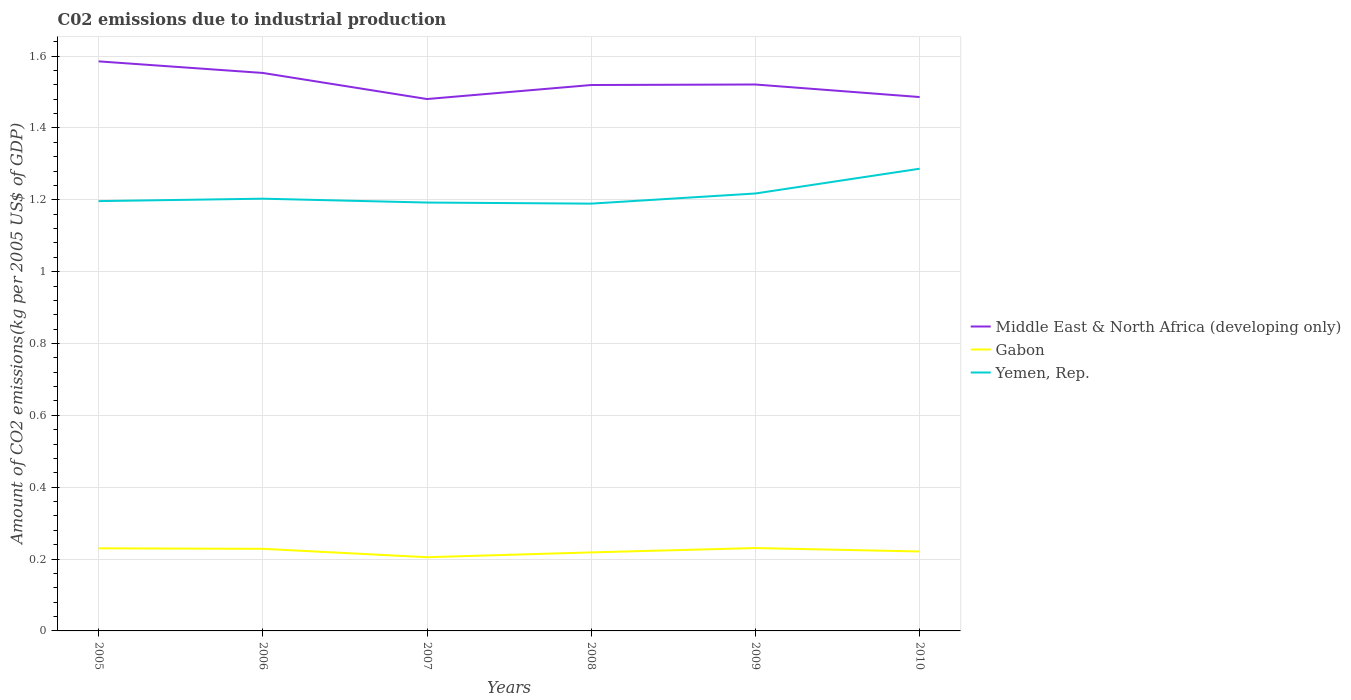Does the line corresponding to Yemen, Rep. intersect with the line corresponding to Gabon?
Your response must be concise. No. Across all years, what is the maximum amount of CO2 emitted due to industrial production in Yemen, Rep.?
Offer a terse response. 1.19. In which year was the amount of CO2 emitted due to industrial production in Yemen, Rep. maximum?
Keep it short and to the point. 2008. What is the total amount of CO2 emitted due to industrial production in Yemen, Rep. in the graph?
Provide a succinct answer. -0.07. What is the difference between the highest and the second highest amount of CO2 emitted due to industrial production in Gabon?
Your answer should be compact. 0.03. What is the difference between the highest and the lowest amount of CO2 emitted due to industrial production in Middle East & North Africa (developing only)?
Your answer should be very brief. 2. How many lines are there?
Your response must be concise. 3. How many years are there in the graph?
Make the answer very short. 6. What is the difference between two consecutive major ticks on the Y-axis?
Provide a short and direct response. 0.2. Are the values on the major ticks of Y-axis written in scientific E-notation?
Give a very brief answer. No. Does the graph contain any zero values?
Provide a succinct answer. No. Does the graph contain grids?
Give a very brief answer. Yes. Where does the legend appear in the graph?
Ensure brevity in your answer.  Center right. How many legend labels are there?
Ensure brevity in your answer.  3. What is the title of the graph?
Give a very brief answer. C02 emissions due to industrial production. What is the label or title of the X-axis?
Provide a succinct answer. Years. What is the label or title of the Y-axis?
Your answer should be compact. Amount of CO2 emissions(kg per 2005 US$ of GDP). What is the Amount of CO2 emissions(kg per 2005 US$ of GDP) in Middle East & North Africa (developing only) in 2005?
Give a very brief answer. 1.59. What is the Amount of CO2 emissions(kg per 2005 US$ of GDP) in Gabon in 2005?
Give a very brief answer. 0.23. What is the Amount of CO2 emissions(kg per 2005 US$ of GDP) in Yemen, Rep. in 2005?
Give a very brief answer. 1.2. What is the Amount of CO2 emissions(kg per 2005 US$ of GDP) in Middle East & North Africa (developing only) in 2006?
Provide a short and direct response. 1.55. What is the Amount of CO2 emissions(kg per 2005 US$ of GDP) in Gabon in 2006?
Make the answer very short. 0.23. What is the Amount of CO2 emissions(kg per 2005 US$ of GDP) of Yemen, Rep. in 2006?
Keep it short and to the point. 1.2. What is the Amount of CO2 emissions(kg per 2005 US$ of GDP) in Middle East & North Africa (developing only) in 2007?
Your answer should be very brief. 1.48. What is the Amount of CO2 emissions(kg per 2005 US$ of GDP) in Gabon in 2007?
Keep it short and to the point. 0.21. What is the Amount of CO2 emissions(kg per 2005 US$ of GDP) in Yemen, Rep. in 2007?
Make the answer very short. 1.19. What is the Amount of CO2 emissions(kg per 2005 US$ of GDP) in Middle East & North Africa (developing only) in 2008?
Offer a very short reply. 1.52. What is the Amount of CO2 emissions(kg per 2005 US$ of GDP) of Gabon in 2008?
Offer a very short reply. 0.22. What is the Amount of CO2 emissions(kg per 2005 US$ of GDP) in Yemen, Rep. in 2008?
Provide a short and direct response. 1.19. What is the Amount of CO2 emissions(kg per 2005 US$ of GDP) in Middle East & North Africa (developing only) in 2009?
Give a very brief answer. 1.52. What is the Amount of CO2 emissions(kg per 2005 US$ of GDP) in Gabon in 2009?
Make the answer very short. 0.23. What is the Amount of CO2 emissions(kg per 2005 US$ of GDP) of Yemen, Rep. in 2009?
Ensure brevity in your answer.  1.22. What is the Amount of CO2 emissions(kg per 2005 US$ of GDP) in Middle East & North Africa (developing only) in 2010?
Keep it short and to the point. 1.49. What is the Amount of CO2 emissions(kg per 2005 US$ of GDP) of Gabon in 2010?
Offer a very short reply. 0.22. What is the Amount of CO2 emissions(kg per 2005 US$ of GDP) of Yemen, Rep. in 2010?
Your answer should be compact. 1.29. Across all years, what is the maximum Amount of CO2 emissions(kg per 2005 US$ of GDP) of Middle East & North Africa (developing only)?
Give a very brief answer. 1.59. Across all years, what is the maximum Amount of CO2 emissions(kg per 2005 US$ of GDP) of Gabon?
Your answer should be very brief. 0.23. Across all years, what is the maximum Amount of CO2 emissions(kg per 2005 US$ of GDP) in Yemen, Rep.?
Provide a short and direct response. 1.29. Across all years, what is the minimum Amount of CO2 emissions(kg per 2005 US$ of GDP) in Middle East & North Africa (developing only)?
Make the answer very short. 1.48. Across all years, what is the minimum Amount of CO2 emissions(kg per 2005 US$ of GDP) of Gabon?
Ensure brevity in your answer.  0.21. Across all years, what is the minimum Amount of CO2 emissions(kg per 2005 US$ of GDP) in Yemen, Rep.?
Your answer should be very brief. 1.19. What is the total Amount of CO2 emissions(kg per 2005 US$ of GDP) in Middle East & North Africa (developing only) in the graph?
Ensure brevity in your answer.  9.15. What is the total Amount of CO2 emissions(kg per 2005 US$ of GDP) of Gabon in the graph?
Your response must be concise. 1.33. What is the total Amount of CO2 emissions(kg per 2005 US$ of GDP) of Yemen, Rep. in the graph?
Give a very brief answer. 7.29. What is the difference between the Amount of CO2 emissions(kg per 2005 US$ of GDP) of Middle East & North Africa (developing only) in 2005 and that in 2006?
Offer a very short reply. 0.03. What is the difference between the Amount of CO2 emissions(kg per 2005 US$ of GDP) of Gabon in 2005 and that in 2006?
Ensure brevity in your answer.  0. What is the difference between the Amount of CO2 emissions(kg per 2005 US$ of GDP) in Yemen, Rep. in 2005 and that in 2006?
Ensure brevity in your answer.  -0.01. What is the difference between the Amount of CO2 emissions(kg per 2005 US$ of GDP) of Middle East & North Africa (developing only) in 2005 and that in 2007?
Offer a terse response. 0.1. What is the difference between the Amount of CO2 emissions(kg per 2005 US$ of GDP) of Gabon in 2005 and that in 2007?
Your answer should be very brief. 0.02. What is the difference between the Amount of CO2 emissions(kg per 2005 US$ of GDP) in Yemen, Rep. in 2005 and that in 2007?
Ensure brevity in your answer.  0. What is the difference between the Amount of CO2 emissions(kg per 2005 US$ of GDP) in Middle East & North Africa (developing only) in 2005 and that in 2008?
Make the answer very short. 0.07. What is the difference between the Amount of CO2 emissions(kg per 2005 US$ of GDP) in Gabon in 2005 and that in 2008?
Your answer should be compact. 0.01. What is the difference between the Amount of CO2 emissions(kg per 2005 US$ of GDP) in Yemen, Rep. in 2005 and that in 2008?
Your answer should be very brief. 0.01. What is the difference between the Amount of CO2 emissions(kg per 2005 US$ of GDP) in Middle East & North Africa (developing only) in 2005 and that in 2009?
Offer a very short reply. 0.06. What is the difference between the Amount of CO2 emissions(kg per 2005 US$ of GDP) in Gabon in 2005 and that in 2009?
Your response must be concise. -0. What is the difference between the Amount of CO2 emissions(kg per 2005 US$ of GDP) of Yemen, Rep. in 2005 and that in 2009?
Give a very brief answer. -0.02. What is the difference between the Amount of CO2 emissions(kg per 2005 US$ of GDP) of Middle East & North Africa (developing only) in 2005 and that in 2010?
Offer a very short reply. 0.1. What is the difference between the Amount of CO2 emissions(kg per 2005 US$ of GDP) in Gabon in 2005 and that in 2010?
Your response must be concise. 0.01. What is the difference between the Amount of CO2 emissions(kg per 2005 US$ of GDP) of Yemen, Rep. in 2005 and that in 2010?
Provide a short and direct response. -0.09. What is the difference between the Amount of CO2 emissions(kg per 2005 US$ of GDP) of Middle East & North Africa (developing only) in 2006 and that in 2007?
Your answer should be compact. 0.07. What is the difference between the Amount of CO2 emissions(kg per 2005 US$ of GDP) of Gabon in 2006 and that in 2007?
Your answer should be compact. 0.02. What is the difference between the Amount of CO2 emissions(kg per 2005 US$ of GDP) of Yemen, Rep. in 2006 and that in 2007?
Your answer should be very brief. 0.01. What is the difference between the Amount of CO2 emissions(kg per 2005 US$ of GDP) in Middle East & North Africa (developing only) in 2006 and that in 2008?
Provide a succinct answer. 0.03. What is the difference between the Amount of CO2 emissions(kg per 2005 US$ of GDP) in Gabon in 2006 and that in 2008?
Give a very brief answer. 0.01. What is the difference between the Amount of CO2 emissions(kg per 2005 US$ of GDP) in Yemen, Rep. in 2006 and that in 2008?
Keep it short and to the point. 0.01. What is the difference between the Amount of CO2 emissions(kg per 2005 US$ of GDP) of Middle East & North Africa (developing only) in 2006 and that in 2009?
Your response must be concise. 0.03. What is the difference between the Amount of CO2 emissions(kg per 2005 US$ of GDP) in Gabon in 2006 and that in 2009?
Provide a short and direct response. -0. What is the difference between the Amount of CO2 emissions(kg per 2005 US$ of GDP) of Yemen, Rep. in 2006 and that in 2009?
Your response must be concise. -0.01. What is the difference between the Amount of CO2 emissions(kg per 2005 US$ of GDP) of Middle East & North Africa (developing only) in 2006 and that in 2010?
Make the answer very short. 0.07. What is the difference between the Amount of CO2 emissions(kg per 2005 US$ of GDP) of Gabon in 2006 and that in 2010?
Your response must be concise. 0.01. What is the difference between the Amount of CO2 emissions(kg per 2005 US$ of GDP) of Yemen, Rep. in 2006 and that in 2010?
Offer a terse response. -0.08. What is the difference between the Amount of CO2 emissions(kg per 2005 US$ of GDP) in Middle East & North Africa (developing only) in 2007 and that in 2008?
Offer a very short reply. -0.04. What is the difference between the Amount of CO2 emissions(kg per 2005 US$ of GDP) of Gabon in 2007 and that in 2008?
Give a very brief answer. -0.01. What is the difference between the Amount of CO2 emissions(kg per 2005 US$ of GDP) in Yemen, Rep. in 2007 and that in 2008?
Offer a very short reply. 0. What is the difference between the Amount of CO2 emissions(kg per 2005 US$ of GDP) of Middle East & North Africa (developing only) in 2007 and that in 2009?
Provide a succinct answer. -0.04. What is the difference between the Amount of CO2 emissions(kg per 2005 US$ of GDP) in Gabon in 2007 and that in 2009?
Provide a short and direct response. -0.03. What is the difference between the Amount of CO2 emissions(kg per 2005 US$ of GDP) in Yemen, Rep. in 2007 and that in 2009?
Provide a short and direct response. -0.03. What is the difference between the Amount of CO2 emissions(kg per 2005 US$ of GDP) of Middle East & North Africa (developing only) in 2007 and that in 2010?
Your answer should be very brief. -0.01. What is the difference between the Amount of CO2 emissions(kg per 2005 US$ of GDP) of Gabon in 2007 and that in 2010?
Offer a terse response. -0.02. What is the difference between the Amount of CO2 emissions(kg per 2005 US$ of GDP) in Yemen, Rep. in 2007 and that in 2010?
Your response must be concise. -0.09. What is the difference between the Amount of CO2 emissions(kg per 2005 US$ of GDP) in Middle East & North Africa (developing only) in 2008 and that in 2009?
Make the answer very short. -0. What is the difference between the Amount of CO2 emissions(kg per 2005 US$ of GDP) in Gabon in 2008 and that in 2009?
Offer a very short reply. -0.01. What is the difference between the Amount of CO2 emissions(kg per 2005 US$ of GDP) of Yemen, Rep. in 2008 and that in 2009?
Your answer should be very brief. -0.03. What is the difference between the Amount of CO2 emissions(kg per 2005 US$ of GDP) of Middle East & North Africa (developing only) in 2008 and that in 2010?
Give a very brief answer. 0.03. What is the difference between the Amount of CO2 emissions(kg per 2005 US$ of GDP) in Gabon in 2008 and that in 2010?
Keep it short and to the point. -0. What is the difference between the Amount of CO2 emissions(kg per 2005 US$ of GDP) in Yemen, Rep. in 2008 and that in 2010?
Your response must be concise. -0.1. What is the difference between the Amount of CO2 emissions(kg per 2005 US$ of GDP) in Middle East & North Africa (developing only) in 2009 and that in 2010?
Your response must be concise. 0.03. What is the difference between the Amount of CO2 emissions(kg per 2005 US$ of GDP) of Gabon in 2009 and that in 2010?
Your answer should be very brief. 0.01. What is the difference between the Amount of CO2 emissions(kg per 2005 US$ of GDP) in Yemen, Rep. in 2009 and that in 2010?
Provide a succinct answer. -0.07. What is the difference between the Amount of CO2 emissions(kg per 2005 US$ of GDP) of Middle East & North Africa (developing only) in 2005 and the Amount of CO2 emissions(kg per 2005 US$ of GDP) of Gabon in 2006?
Offer a very short reply. 1.36. What is the difference between the Amount of CO2 emissions(kg per 2005 US$ of GDP) of Middle East & North Africa (developing only) in 2005 and the Amount of CO2 emissions(kg per 2005 US$ of GDP) of Yemen, Rep. in 2006?
Provide a succinct answer. 0.38. What is the difference between the Amount of CO2 emissions(kg per 2005 US$ of GDP) in Gabon in 2005 and the Amount of CO2 emissions(kg per 2005 US$ of GDP) in Yemen, Rep. in 2006?
Your response must be concise. -0.97. What is the difference between the Amount of CO2 emissions(kg per 2005 US$ of GDP) in Middle East & North Africa (developing only) in 2005 and the Amount of CO2 emissions(kg per 2005 US$ of GDP) in Gabon in 2007?
Provide a succinct answer. 1.38. What is the difference between the Amount of CO2 emissions(kg per 2005 US$ of GDP) in Middle East & North Africa (developing only) in 2005 and the Amount of CO2 emissions(kg per 2005 US$ of GDP) in Yemen, Rep. in 2007?
Your response must be concise. 0.39. What is the difference between the Amount of CO2 emissions(kg per 2005 US$ of GDP) in Gabon in 2005 and the Amount of CO2 emissions(kg per 2005 US$ of GDP) in Yemen, Rep. in 2007?
Offer a terse response. -0.96. What is the difference between the Amount of CO2 emissions(kg per 2005 US$ of GDP) of Middle East & North Africa (developing only) in 2005 and the Amount of CO2 emissions(kg per 2005 US$ of GDP) of Gabon in 2008?
Make the answer very short. 1.37. What is the difference between the Amount of CO2 emissions(kg per 2005 US$ of GDP) in Middle East & North Africa (developing only) in 2005 and the Amount of CO2 emissions(kg per 2005 US$ of GDP) in Yemen, Rep. in 2008?
Your answer should be compact. 0.4. What is the difference between the Amount of CO2 emissions(kg per 2005 US$ of GDP) in Gabon in 2005 and the Amount of CO2 emissions(kg per 2005 US$ of GDP) in Yemen, Rep. in 2008?
Provide a succinct answer. -0.96. What is the difference between the Amount of CO2 emissions(kg per 2005 US$ of GDP) of Middle East & North Africa (developing only) in 2005 and the Amount of CO2 emissions(kg per 2005 US$ of GDP) of Gabon in 2009?
Your answer should be compact. 1.35. What is the difference between the Amount of CO2 emissions(kg per 2005 US$ of GDP) in Middle East & North Africa (developing only) in 2005 and the Amount of CO2 emissions(kg per 2005 US$ of GDP) in Yemen, Rep. in 2009?
Your answer should be compact. 0.37. What is the difference between the Amount of CO2 emissions(kg per 2005 US$ of GDP) in Gabon in 2005 and the Amount of CO2 emissions(kg per 2005 US$ of GDP) in Yemen, Rep. in 2009?
Your answer should be compact. -0.99. What is the difference between the Amount of CO2 emissions(kg per 2005 US$ of GDP) in Middle East & North Africa (developing only) in 2005 and the Amount of CO2 emissions(kg per 2005 US$ of GDP) in Gabon in 2010?
Give a very brief answer. 1.36. What is the difference between the Amount of CO2 emissions(kg per 2005 US$ of GDP) of Middle East & North Africa (developing only) in 2005 and the Amount of CO2 emissions(kg per 2005 US$ of GDP) of Yemen, Rep. in 2010?
Offer a very short reply. 0.3. What is the difference between the Amount of CO2 emissions(kg per 2005 US$ of GDP) of Gabon in 2005 and the Amount of CO2 emissions(kg per 2005 US$ of GDP) of Yemen, Rep. in 2010?
Make the answer very short. -1.06. What is the difference between the Amount of CO2 emissions(kg per 2005 US$ of GDP) of Middle East & North Africa (developing only) in 2006 and the Amount of CO2 emissions(kg per 2005 US$ of GDP) of Gabon in 2007?
Your answer should be compact. 1.35. What is the difference between the Amount of CO2 emissions(kg per 2005 US$ of GDP) in Middle East & North Africa (developing only) in 2006 and the Amount of CO2 emissions(kg per 2005 US$ of GDP) in Yemen, Rep. in 2007?
Offer a very short reply. 0.36. What is the difference between the Amount of CO2 emissions(kg per 2005 US$ of GDP) of Gabon in 2006 and the Amount of CO2 emissions(kg per 2005 US$ of GDP) of Yemen, Rep. in 2007?
Offer a very short reply. -0.96. What is the difference between the Amount of CO2 emissions(kg per 2005 US$ of GDP) of Middle East & North Africa (developing only) in 2006 and the Amount of CO2 emissions(kg per 2005 US$ of GDP) of Gabon in 2008?
Your answer should be compact. 1.33. What is the difference between the Amount of CO2 emissions(kg per 2005 US$ of GDP) in Middle East & North Africa (developing only) in 2006 and the Amount of CO2 emissions(kg per 2005 US$ of GDP) in Yemen, Rep. in 2008?
Offer a terse response. 0.36. What is the difference between the Amount of CO2 emissions(kg per 2005 US$ of GDP) in Gabon in 2006 and the Amount of CO2 emissions(kg per 2005 US$ of GDP) in Yemen, Rep. in 2008?
Ensure brevity in your answer.  -0.96. What is the difference between the Amount of CO2 emissions(kg per 2005 US$ of GDP) in Middle East & North Africa (developing only) in 2006 and the Amount of CO2 emissions(kg per 2005 US$ of GDP) in Gabon in 2009?
Your answer should be compact. 1.32. What is the difference between the Amount of CO2 emissions(kg per 2005 US$ of GDP) in Middle East & North Africa (developing only) in 2006 and the Amount of CO2 emissions(kg per 2005 US$ of GDP) in Yemen, Rep. in 2009?
Give a very brief answer. 0.34. What is the difference between the Amount of CO2 emissions(kg per 2005 US$ of GDP) in Gabon in 2006 and the Amount of CO2 emissions(kg per 2005 US$ of GDP) in Yemen, Rep. in 2009?
Your answer should be very brief. -0.99. What is the difference between the Amount of CO2 emissions(kg per 2005 US$ of GDP) in Middle East & North Africa (developing only) in 2006 and the Amount of CO2 emissions(kg per 2005 US$ of GDP) in Gabon in 2010?
Your answer should be compact. 1.33. What is the difference between the Amount of CO2 emissions(kg per 2005 US$ of GDP) in Middle East & North Africa (developing only) in 2006 and the Amount of CO2 emissions(kg per 2005 US$ of GDP) in Yemen, Rep. in 2010?
Give a very brief answer. 0.27. What is the difference between the Amount of CO2 emissions(kg per 2005 US$ of GDP) in Gabon in 2006 and the Amount of CO2 emissions(kg per 2005 US$ of GDP) in Yemen, Rep. in 2010?
Your answer should be compact. -1.06. What is the difference between the Amount of CO2 emissions(kg per 2005 US$ of GDP) in Middle East & North Africa (developing only) in 2007 and the Amount of CO2 emissions(kg per 2005 US$ of GDP) in Gabon in 2008?
Keep it short and to the point. 1.26. What is the difference between the Amount of CO2 emissions(kg per 2005 US$ of GDP) in Middle East & North Africa (developing only) in 2007 and the Amount of CO2 emissions(kg per 2005 US$ of GDP) in Yemen, Rep. in 2008?
Ensure brevity in your answer.  0.29. What is the difference between the Amount of CO2 emissions(kg per 2005 US$ of GDP) in Gabon in 2007 and the Amount of CO2 emissions(kg per 2005 US$ of GDP) in Yemen, Rep. in 2008?
Your response must be concise. -0.98. What is the difference between the Amount of CO2 emissions(kg per 2005 US$ of GDP) in Middle East & North Africa (developing only) in 2007 and the Amount of CO2 emissions(kg per 2005 US$ of GDP) in Gabon in 2009?
Your answer should be very brief. 1.25. What is the difference between the Amount of CO2 emissions(kg per 2005 US$ of GDP) in Middle East & North Africa (developing only) in 2007 and the Amount of CO2 emissions(kg per 2005 US$ of GDP) in Yemen, Rep. in 2009?
Make the answer very short. 0.26. What is the difference between the Amount of CO2 emissions(kg per 2005 US$ of GDP) of Gabon in 2007 and the Amount of CO2 emissions(kg per 2005 US$ of GDP) of Yemen, Rep. in 2009?
Provide a short and direct response. -1.01. What is the difference between the Amount of CO2 emissions(kg per 2005 US$ of GDP) in Middle East & North Africa (developing only) in 2007 and the Amount of CO2 emissions(kg per 2005 US$ of GDP) in Gabon in 2010?
Offer a terse response. 1.26. What is the difference between the Amount of CO2 emissions(kg per 2005 US$ of GDP) in Middle East & North Africa (developing only) in 2007 and the Amount of CO2 emissions(kg per 2005 US$ of GDP) in Yemen, Rep. in 2010?
Offer a terse response. 0.19. What is the difference between the Amount of CO2 emissions(kg per 2005 US$ of GDP) in Gabon in 2007 and the Amount of CO2 emissions(kg per 2005 US$ of GDP) in Yemen, Rep. in 2010?
Provide a succinct answer. -1.08. What is the difference between the Amount of CO2 emissions(kg per 2005 US$ of GDP) of Middle East & North Africa (developing only) in 2008 and the Amount of CO2 emissions(kg per 2005 US$ of GDP) of Gabon in 2009?
Give a very brief answer. 1.29. What is the difference between the Amount of CO2 emissions(kg per 2005 US$ of GDP) in Middle East & North Africa (developing only) in 2008 and the Amount of CO2 emissions(kg per 2005 US$ of GDP) in Yemen, Rep. in 2009?
Ensure brevity in your answer.  0.3. What is the difference between the Amount of CO2 emissions(kg per 2005 US$ of GDP) in Gabon in 2008 and the Amount of CO2 emissions(kg per 2005 US$ of GDP) in Yemen, Rep. in 2009?
Keep it short and to the point. -1. What is the difference between the Amount of CO2 emissions(kg per 2005 US$ of GDP) in Middle East & North Africa (developing only) in 2008 and the Amount of CO2 emissions(kg per 2005 US$ of GDP) in Gabon in 2010?
Your answer should be compact. 1.3. What is the difference between the Amount of CO2 emissions(kg per 2005 US$ of GDP) in Middle East & North Africa (developing only) in 2008 and the Amount of CO2 emissions(kg per 2005 US$ of GDP) in Yemen, Rep. in 2010?
Give a very brief answer. 0.23. What is the difference between the Amount of CO2 emissions(kg per 2005 US$ of GDP) of Gabon in 2008 and the Amount of CO2 emissions(kg per 2005 US$ of GDP) of Yemen, Rep. in 2010?
Offer a terse response. -1.07. What is the difference between the Amount of CO2 emissions(kg per 2005 US$ of GDP) in Middle East & North Africa (developing only) in 2009 and the Amount of CO2 emissions(kg per 2005 US$ of GDP) in Gabon in 2010?
Make the answer very short. 1.3. What is the difference between the Amount of CO2 emissions(kg per 2005 US$ of GDP) in Middle East & North Africa (developing only) in 2009 and the Amount of CO2 emissions(kg per 2005 US$ of GDP) in Yemen, Rep. in 2010?
Provide a short and direct response. 0.23. What is the difference between the Amount of CO2 emissions(kg per 2005 US$ of GDP) in Gabon in 2009 and the Amount of CO2 emissions(kg per 2005 US$ of GDP) in Yemen, Rep. in 2010?
Provide a succinct answer. -1.06. What is the average Amount of CO2 emissions(kg per 2005 US$ of GDP) of Middle East & North Africa (developing only) per year?
Your answer should be very brief. 1.52. What is the average Amount of CO2 emissions(kg per 2005 US$ of GDP) of Gabon per year?
Your answer should be compact. 0.22. What is the average Amount of CO2 emissions(kg per 2005 US$ of GDP) in Yemen, Rep. per year?
Give a very brief answer. 1.21. In the year 2005, what is the difference between the Amount of CO2 emissions(kg per 2005 US$ of GDP) in Middle East & North Africa (developing only) and Amount of CO2 emissions(kg per 2005 US$ of GDP) in Gabon?
Keep it short and to the point. 1.36. In the year 2005, what is the difference between the Amount of CO2 emissions(kg per 2005 US$ of GDP) in Middle East & North Africa (developing only) and Amount of CO2 emissions(kg per 2005 US$ of GDP) in Yemen, Rep.?
Your answer should be compact. 0.39. In the year 2005, what is the difference between the Amount of CO2 emissions(kg per 2005 US$ of GDP) in Gabon and Amount of CO2 emissions(kg per 2005 US$ of GDP) in Yemen, Rep.?
Offer a terse response. -0.97. In the year 2006, what is the difference between the Amount of CO2 emissions(kg per 2005 US$ of GDP) of Middle East & North Africa (developing only) and Amount of CO2 emissions(kg per 2005 US$ of GDP) of Gabon?
Ensure brevity in your answer.  1.32. In the year 2006, what is the difference between the Amount of CO2 emissions(kg per 2005 US$ of GDP) in Middle East & North Africa (developing only) and Amount of CO2 emissions(kg per 2005 US$ of GDP) in Yemen, Rep.?
Your answer should be compact. 0.35. In the year 2006, what is the difference between the Amount of CO2 emissions(kg per 2005 US$ of GDP) in Gabon and Amount of CO2 emissions(kg per 2005 US$ of GDP) in Yemen, Rep.?
Your response must be concise. -0.97. In the year 2007, what is the difference between the Amount of CO2 emissions(kg per 2005 US$ of GDP) in Middle East & North Africa (developing only) and Amount of CO2 emissions(kg per 2005 US$ of GDP) in Gabon?
Keep it short and to the point. 1.28. In the year 2007, what is the difference between the Amount of CO2 emissions(kg per 2005 US$ of GDP) in Middle East & North Africa (developing only) and Amount of CO2 emissions(kg per 2005 US$ of GDP) in Yemen, Rep.?
Keep it short and to the point. 0.29. In the year 2007, what is the difference between the Amount of CO2 emissions(kg per 2005 US$ of GDP) in Gabon and Amount of CO2 emissions(kg per 2005 US$ of GDP) in Yemen, Rep.?
Your answer should be compact. -0.99. In the year 2008, what is the difference between the Amount of CO2 emissions(kg per 2005 US$ of GDP) of Middle East & North Africa (developing only) and Amount of CO2 emissions(kg per 2005 US$ of GDP) of Gabon?
Ensure brevity in your answer.  1.3. In the year 2008, what is the difference between the Amount of CO2 emissions(kg per 2005 US$ of GDP) of Middle East & North Africa (developing only) and Amount of CO2 emissions(kg per 2005 US$ of GDP) of Yemen, Rep.?
Keep it short and to the point. 0.33. In the year 2008, what is the difference between the Amount of CO2 emissions(kg per 2005 US$ of GDP) of Gabon and Amount of CO2 emissions(kg per 2005 US$ of GDP) of Yemen, Rep.?
Keep it short and to the point. -0.97. In the year 2009, what is the difference between the Amount of CO2 emissions(kg per 2005 US$ of GDP) of Middle East & North Africa (developing only) and Amount of CO2 emissions(kg per 2005 US$ of GDP) of Gabon?
Your answer should be very brief. 1.29. In the year 2009, what is the difference between the Amount of CO2 emissions(kg per 2005 US$ of GDP) of Middle East & North Africa (developing only) and Amount of CO2 emissions(kg per 2005 US$ of GDP) of Yemen, Rep.?
Offer a terse response. 0.3. In the year 2009, what is the difference between the Amount of CO2 emissions(kg per 2005 US$ of GDP) of Gabon and Amount of CO2 emissions(kg per 2005 US$ of GDP) of Yemen, Rep.?
Give a very brief answer. -0.99. In the year 2010, what is the difference between the Amount of CO2 emissions(kg per 2005 US$ of GDP) of Middle East & North Africa (developing only) and Amount of CO2 emissions(kg per 2005 US$ of GDP) of Gabon?
Offer a very short reply. 1.26. In the year 2010, what is the difference between the Amount of CO2 emissions(kg per 2005 US$ of GDP) of Middle East & North Africa (developing only) and Amount of CO2 emissions(kg per 2005 US$ of GDP) of Yemen, Rep.?
Provide a short and direct response. 0.2. In the year 2010, what is the difference between the Amount of CO2 emissions(kg per 2005 US$ of GDP) of Gabon and Amount of CO2 emissions(kg per 2005 US$ of GDP) of Yemen, Rep.?
Make the answer very short. -1.07. What is the ratio of the Amount of CO2 emissions(kg per 2005 US$ of GDP) of Middle East & North Africa (developing only) in 2005 to that in 2006?
Your response must be concise. 1.02. What is the ratio of the Amount of CO2 emissions(kg per 2005 US$ of GDP) in Yemen, Rep. in 2005 to that in 2006?
Make the answer very short. 0.99. What is the ratio of the Amount of CO2 emissions(kg per 2005 US$ of GDP) in Middle East & North Africa (developing only) in 2005 to that in 2007?
Your answer should be compact. 1.07. What is the ratio of the Amount of CO2 emissions(kg per 2005 US$ of GDP) of Gabon in 2005 to that in 2007?
Provide a succinct answer. 1.12. What is the ratio of the Amount of CO2 emissions(kg per 2005 US$ of GDP) in Middle East & North Africa (developing only) in 2005 to that in 2008?
Keep it short and to the point. 1.04. What is the ratio of the Amount of CO2 emissions(kg per 2005 US$ of GDP) of Gabon in 2005 to that in 2008?
Keep it short and to the point. 1.05. What is the ratio of the Amount of CO2 emissions(kg per 2005 US$ of GDP) of Yemen, Rep. in 2005 to that in 2008?
Offer a very short reply. 1.01. What is the ratio of the Amount of CO2 emissions(kg per 2005 US$ of GDP) of Middle East & North Africa (developing only) in 2005 to that in 2009?
Ensure brevity in your answer.  1.04. What is the ratio of the Amount of CO2 emissions(kg per 2005 US$ of GDP) of Gabon in 2005 to that in 2009?
Offer a very short reply. 1. What is the ratio of the Amount of CO2 emissions(kg per 2005 US$ of GDP) of Yemen, Rep. in 2005 to that in 2009?
Provide a short and direct response. 0.98. What is the ratio of the Amount of CO2 emissions(kg per 2005 US$ of GDP) in Middle East & North Africa (developing only) in 2005 to that in 2010?
Keep it short and to the point. 1.07. What is the ratio of the Amount of CO2 emissions(kg per 2005 US$ of GDP) in Gabon in 2005 to that in 2010?
Your answer should be compact. 1.04. What is the ratio of the Amount of CO2 emissions(kg per 2005 US$ of GDP) in Yemen, Rep. in 2005 to that in 2010?
Your answer should be very brief. 0.93. What is the ratio of the Amount of CO2 emissions(kg per 2005 US$ of GDP) of Middle East & North Africa (developing only) in 2006 to that in 2007?
Make the answer very short. 1.05. What is the ratio of the Amount of CO2 emissions(kg per 2005 US$ of GDP) of Gabon in 2006 to that in 2007?
Keep it short and to the point. 1.11. What is the ratio of the Amount of CO2 emissions(kg per 2005 US$ of GDP) of Yemen, Rep. in 2006 to that in 2007?
Keep it short and to the point. 1.01. What is the ratio of the Amount of CO2 emissions(kg per 2005 US$ of GDP) in Middle East & North Africa (developing only) in 2006 to that in 2008?
Give a very brief answer. 1.02. What is the ratio of the Amount of CO2 emissions(kg per 2005 US$ of GDP) in Gabon in 2006 to that in 2008?
Provide a succinct answer. 1.05. What is the ratio of the Amount of CO2 emissions(kg per 2005 US$ of GDP) in Yemen, Rep. in 2006 to that in 2008?
Give a very brief answer. 1.01. What is the ratio of the Amount of CO2 emissions(kg per 2005 US$ of GDP) of Middle East & North Africa (developing only) in 2006 to that in 2009?
Provide a short and direct response. 1.02. What is the ratio of the Amount of CO2 emissions(kg per 2005 US$ of GDP) in Gabon in 2006 to that in 2009?
Provide a succinct answer. 0.99. What is the ratio of the Amount of CO2 emissions(kg per 2005 US$ of GDP) in Middle East & North Africa (developing only) in 2006 to that in 2010?
Your answer should be very brief. 1.05. What is the ratio of the Amount of CO2 emissions(kg per 2005 US$ of GDP) in Gabon in 2006 to that in 2010?
Your response must be concise. 1.03. What is the ratio of the Amount of CO2 emissions(kg per 2005 US$ of GDP) of Yemen, Rep. in 2006 to that in 2010?
Offer a terse response. 0.94. What is the ratio of the Amount of CO2 emissions(kg per 2005 US$ of GDP) in Middle East & North Africa (developing only) in 2007 to that in 2008?
Provide a short and direct response. 0.97. What is the ratio of the Amount of CO2 emissions(kg per 2005 US$ of GDP) in Gabon in 2007 to that in 2008?
Provide a succinct answer. 0.94. What is the ratio of the Amount of CO2 emissions(kg per 2005 US$ of GDP) in Yemen, Rep. in 2007 to that in 2008?
Ensure brevity in your answer.  1. What is the ratio of the Amount of CO2 emissions(kg per 2005 US$ of GDP) of Middle East & North Africa (developing only) in 2007 to that in 2009?
Offer a very short reply. 0.97. What is the ratio of the Amount of CO2 emissions(kg per 2005 US$ of GDP) in Gabon in 2007 to that in 2009?
Keep it short and to the point. 0.89. What is the ratio of the Amount of CO2 emissions(kg per 2005 US$ of GDP) in Yemen, Rep. in 2007 to that in 2009?
Give a very brief answer. 0.98. What is the ratio of the Amount of CO2 emissions(kg per 2005 US$ of GDP) of Middle East & North Africa (developing only) in 2007 to that in 2010?
Give a very brief answer. 1. What is the ratio of the Amount of CO2 emissions(kg per 2005 US$ of GDP) in Gabon in 2007 to that in 2010?
Give a very brief answer. 0.93. What is the ratio of the Amount of CO2 emissions(kg per 2005 US$ of GDP) of Yemen, Rep. in 2007 to that in 2010?
Offer a terse response. 0.93. What is the ratio of the Amount of CO2 emissions(kg per 2005 US$ of GDP) of Middle East & North Africa (developing only) in 2008 to that in 2009?
Ensure brevity in your answer.  1. What is the ratio of the Amount of CO2 emissions(kg per 2005 US$ of GDP) in Gabon in 2008 to that in 2009?
Offer a very short reply. 0.95. What is the ratio of the Amount of CO2 emissions(kg per 2005 US$ of GDP) in Yemen, Rep. in 2008 to that in 2009?
Offer a very short reply. 0.98. What is the ratio of the Amount of CO2 emissions(kg per 2005 US$ of GDP) of Middle East & North Africa (developing only) in 2008 to that in 2010?
Your answer should be compact. 1.02. What is the ratio of the Amount of CO2 emissions(kg per 2005 US$ of GDP) in Gabon in 2008 to that in 2010?
Offer a terse response. 0.99. What is the ratio of the Amount of CO2 emissions(kg per 2005 US$ of GDP) of Yemen, Rep. in 2008 to that in 2010?
Offer a very short reply. 0.92. What is the ratio of the Amount of CO2 emissions(kg per 2005 US$ of GDP) of Middle East & North Africa (developing only) in 2009 to that in 2010?
Offer a very short reply. 1.02. What is the ratio of the Amount of CO2 emissions(kg per 2005 US$ of GDP) of Gabon in 2009 to that in 2010?
Your response must be concise. 1.04. What is the ratio of the Amount of CO2 emissions(kg per 2005 US$ of GDP) in Yemen, Rep. in 2009 to that in 2010?
Provide a short and direct response. 0.95. What is the difference between the highest and the second highest Amount of CO2 emissions(kg per 2005 US$ of GDP) of Middle East & North Africa (developing only)?
Offer a very short reply. 0.03. What is the difference between the highest and the second highest Amount of CO2 emissions(kg per 2005 US$ of GDP) in Gabon?
Your answer should be compact. 0. What is the difference between the highest and the second highest Amount of CO2 emissions(kg per 2005 US$ of GDP) of Yemen, Rep.?
Offer a very short reply. 0.07. What is the difference between the highest and the lowest Amount of CO2 emissions(kg per 2005 US$ of GDP) in Middle East & North Africa (developing only)?
Your response must be concise. 0.1. What is the difference between the highest and the lowest Amount of CO2 emissions(kg per 2005 US$ of GDP) in Gabon?
Ensure brevity in your answer.  0.03. What is the difference between the highest and the lowest Amount of CO2 emissions(kg per 2005 US$ of GDP) in Yemen, Rep.?
Your response must be concise. 0.1. 